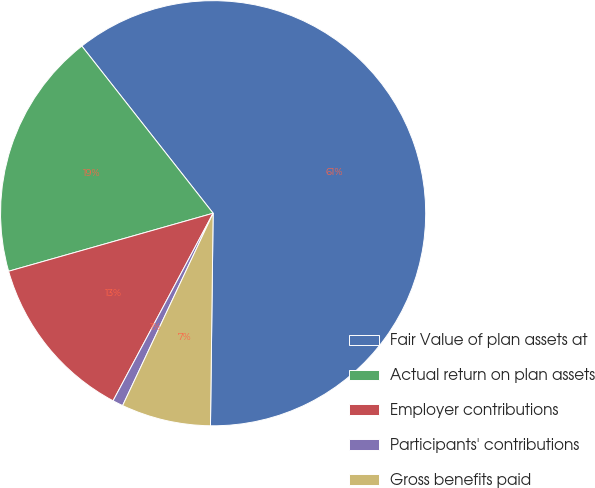Convert chart. <chart><loc_0><loc_0><loc_500><loc_500><pie_chart><fcel>Fair Value of plan assets at<fcel>Actual return on plan assets<fcel>Employer contributions<fcel>Participants' contributions<fcel>Gross benefits paid<nl><fcel>60.79%<fcel>18.8%<fcel>12.8%<fcel>0.8%<fcel>6.8%<nl></chart> 